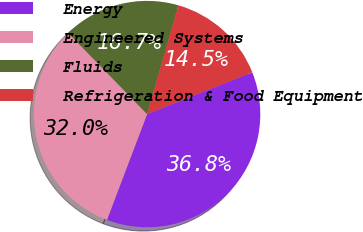Convert chart. <chart><loc_0><loc_0><loc_500><loc_500><pie_chart><fcel>Energy<fcel>Engineered Systems<fcel>Fluids<fcel>Refrigeration & Food Equipment<nl><fcel>36.8%<fcel>31.96%<fcel>16.74%<fcel>14.51%<nl></chart> 